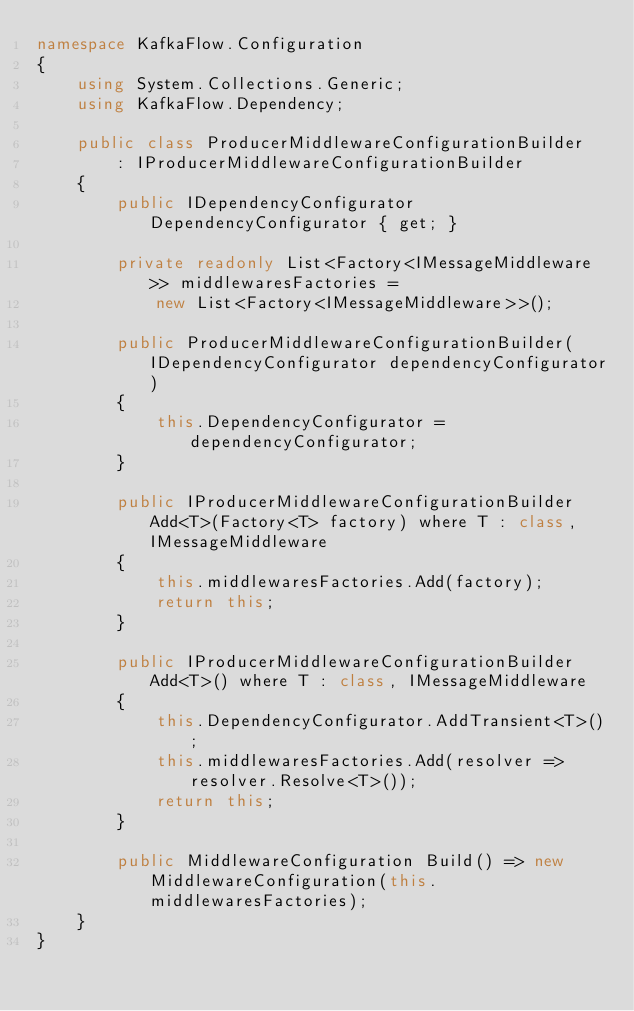<code> <loc_0><loc_0><loc_500><loc_500><_C#_>namespace KafkaFlow.Configuration
{
    using System.Collections.Generic;
    using KafkaFlow.Dependency;

    public class ProducerMiddlewareConfigurationBuilder
        : IProducerMiddlewareConfigurationBuilder
    {
        public IDependencyConfigurator DependencyConfigurator { get; }

        private readonly List<Factory<IMessageMiddleware>> middlewaresFactories =
            new List<Factory<IMessageMiddleware>>();

        public ProducerMiddlewareConfigurationBuilder(IDependencyConfigurator dependencyConfigurator)
        {
            this.DependencyConfigurator = dependencyConfigurator;
        }

        public IProducerMiddlewareConfigurationBuilder Add<T>(Factory<T> factory) where T : class, IMessageMiddleware
        {
            this.middlewaresFactories.Add(factory);
            return this;
        }

        public IProducerMiddlewareConfigurationBuilder Add<T>() where T : class, IMessageMiddleware
        {
            this.DependencyConfigurator.AddTransient<T>();
            this.middlewaresFactories.Add(resolver => resolver.Resolve<T>());
            return this;
        }

        public MiddlewareConfiguration Build() => new MiddlewareConfiguration(this.middlewaresFactories);
    }
}
</code> 